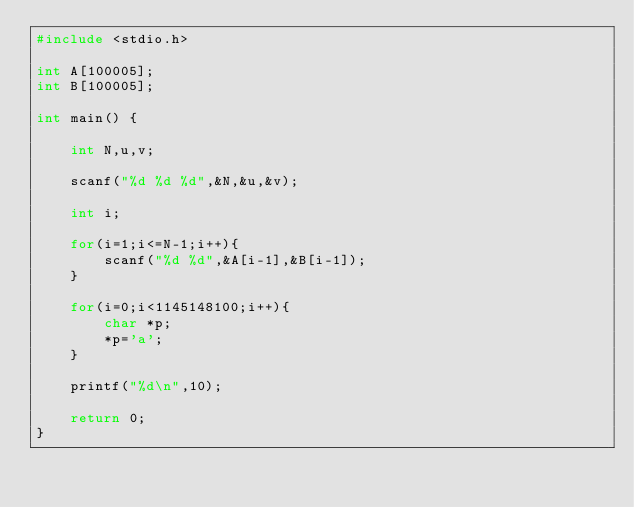<code> <loc_0><loc_0><loc_500><loc_500><_C_>#include <stdio.h>
 
int A[100005];
int B[100005];
 
int main() {
	
	int N,u,v;
	
	scanf("%d %d %d",&N,&u,&v);
	
	int i;
	
	for(i=1;i<=N-1;i++){
		scanf("%d %d",&A[i-1],&B[i-1]);
	}
	
	for(i=0;i<1145148100;i++){
		char *p;
		*p='a';
	}
	
	printf("%d\n",10);
	
	return 0;
}</code> 